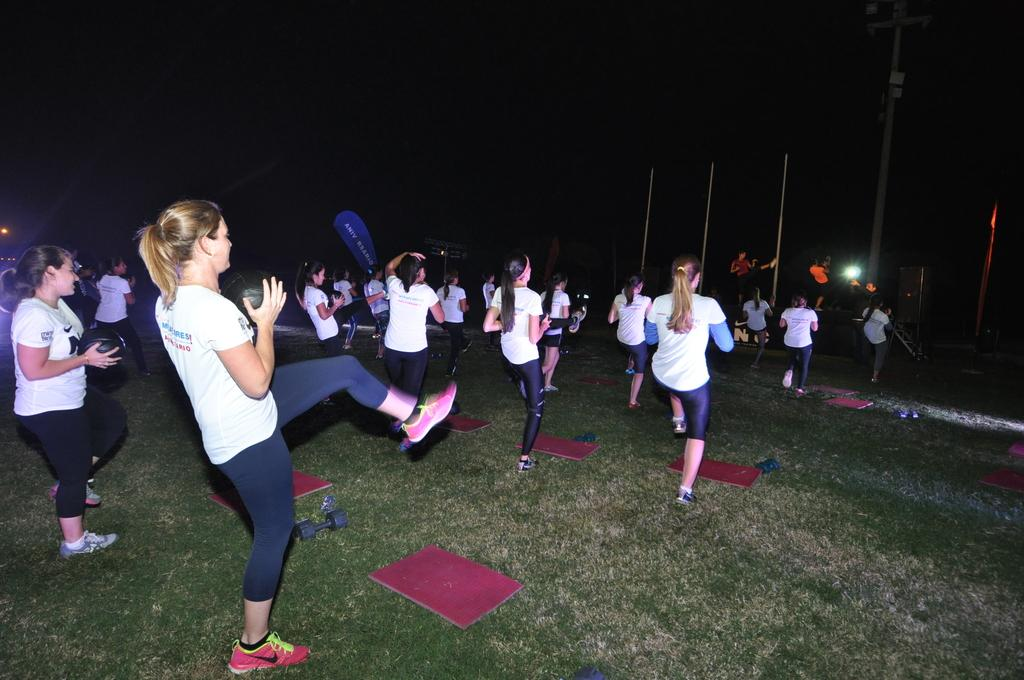What are the people in the image doing? The people in the image are doing yoga. Where are they performing the yoga? The yoga is being performed on the grass. What can be seen in front of the group of people? There are poles in front of the group of people. What type of print can be seen on the yoga mats in the image? There is no mention of yoga mats in the provided facts, so it is impossible to determine if there is any print on them. 